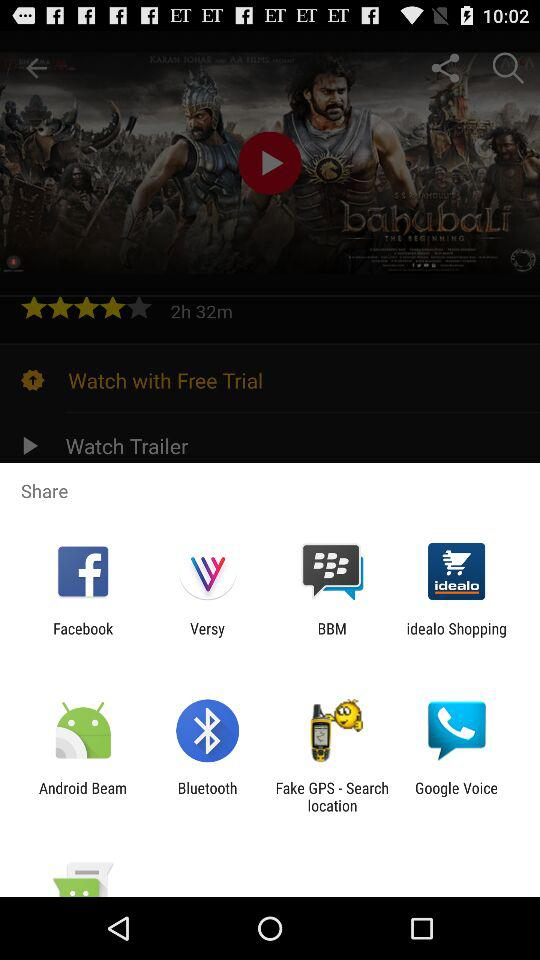What are the sharing options? The sharing options are "Facebook", "Versy", "BBM", "idealo Shopping", "Android Beam", "Bluetooth", "Fake GPS - Search location" and "Google Voice". 